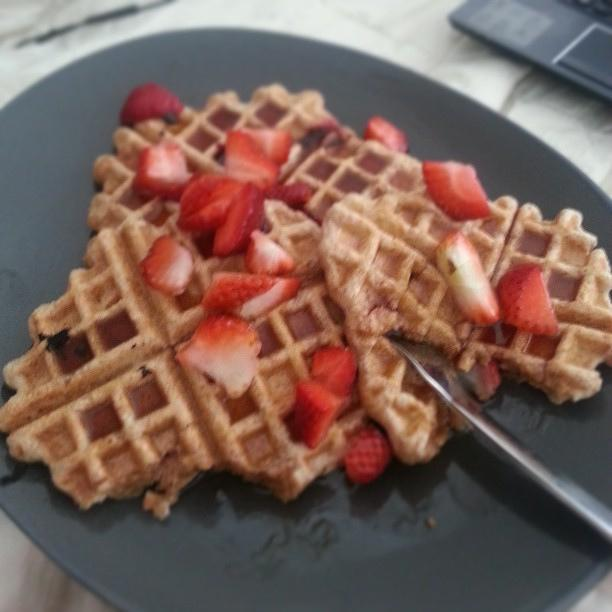What is most likely to be added to this food item? syrup 